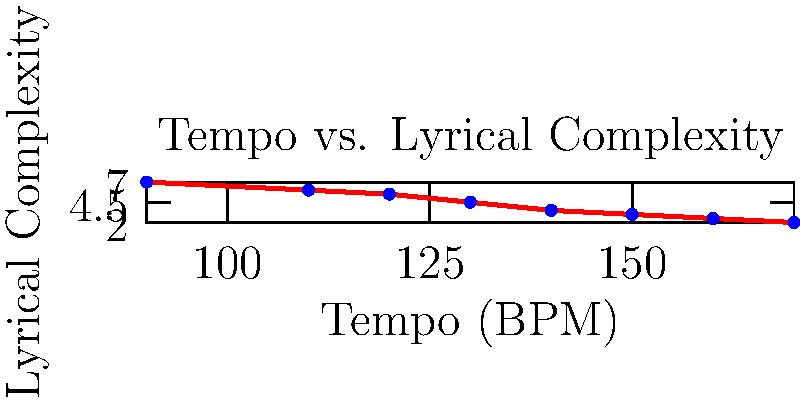Based on the scatter plot showing the relationship between tempo and lyrical complexity in dance music, what can be concluded about the trend, and how might this impact a lyricist's approach to writing for different tempos? 1. Observe the overall trend: As we move from left to right (increasing tempo), the points generally move downward (decreasing lyrical complexity).

2. Identify the correlation: There's a negative correlation between tempo and lyrical complexity.

3. Interpret the relationship: As the tempo of the music increases, the lyrical complexity tends to decrease.

4. Consider the implications for lyricists:
   a. For slower tempos (e.g., 90-110 BPM), there's more room for complex, intricate lyrics.
   b. For faster tempos (e.g., 150-170 BPM), simpler, more repetitive lyrics might be more suitable.

5. Reflect on the balance: Lyricists need to adapt their writing style to complement the tempo while still maintaining meaningful content.

6. Think about exceptions: Some points deviate slightly from the trend, suggesting that skilled lyricists can occasionally subvert this pattern.

7. Consider genre conventions: Different dance music subgenres may have varying expectations for lyrical complexity at similar tempos.
Answer: Negative correlation; lyricists should simplify lyrics as tempo increases, balancing complexity with danceability. 